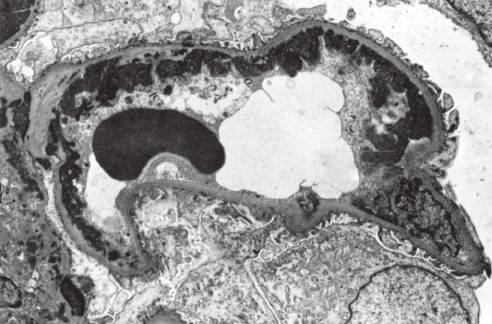what do subendothelial dense deposits correspond to?
Answer the question using a single word or phrase. Wire loops seen by light microscopy 